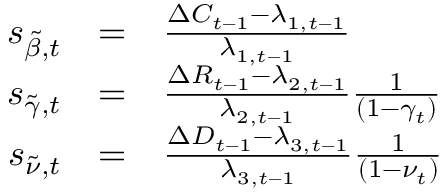Convert formula to latex. <formula><loc_0><loc_0><loc_500><loc_500>\begin{array} { r c l } { s _ { \tilde { \beta } , t } } & { = } & { \frac { \Delta C _ { t - 1 } - \lambda _ { 1 , t - 1 } } { \lambda _ { 1 , t - 1 } } } \\ { s _ { \tilde { \gamma } , t } } & { = } & { \frac { \Delta R _ { t - 1 } - \lambda _ { 2 , t - 1 } } { \lambda _ { 2 , t - 1 } } \frac { 1 } { ( 1 - \gamma _ { t } ) } } \\ { s _ { \tilde { \nu } , t } } & { = } & { \frac { \Delta D _ { t - 1 } - \lambda _ { 3 , t - 1 } } { \lambda _ { 3 , t - 1 } } \frac { 1 } { ( 1 - \nu _ { t } ) } } \end{array}</formula> 